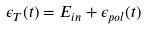Convert formula to latex. <formula><loc_0><loc_0><loc_500><loc_500>\epsilon _ { T } ( t ) = E _ { i n } + \epsilon _ { p o l } ( t )</formula> 